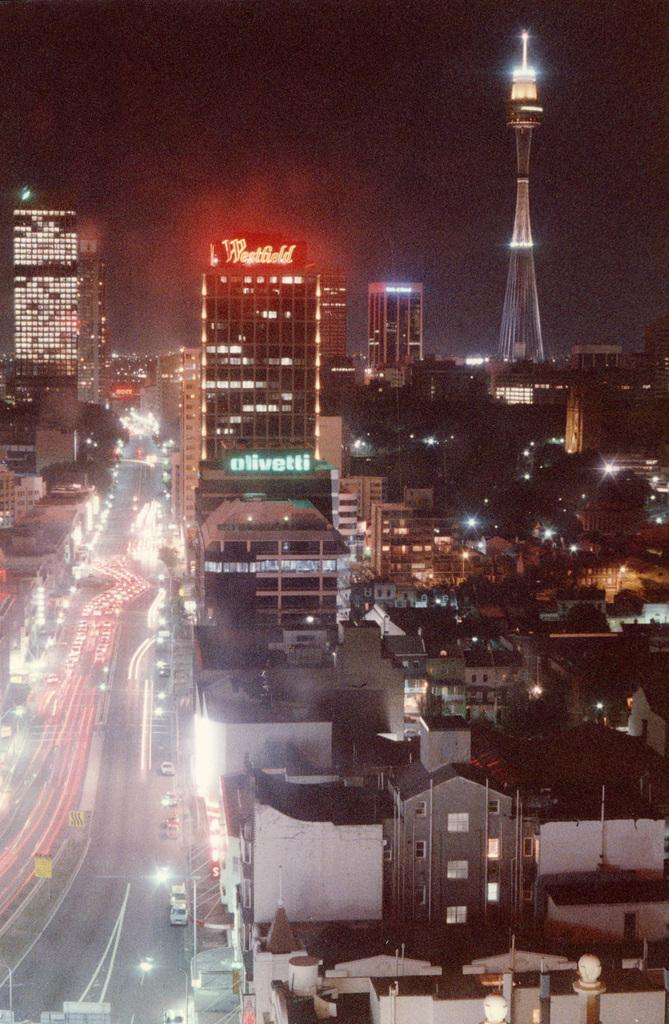What can be seen on the road in the image? There are vehicles on the road in the image. What is located on the right side of the image? There is a tower with lights on the right side of the image. What type of structures are present in the image? There are buildings in the image. What other natural elements can be seen in the image? There are trees in the image. What is visible at the top of the image? The sky is visible at the top of the image. Where are the scissors used in the image? There are no scissors present in the image. What type of office is depicted in the image? There is no office depicted in the image. 